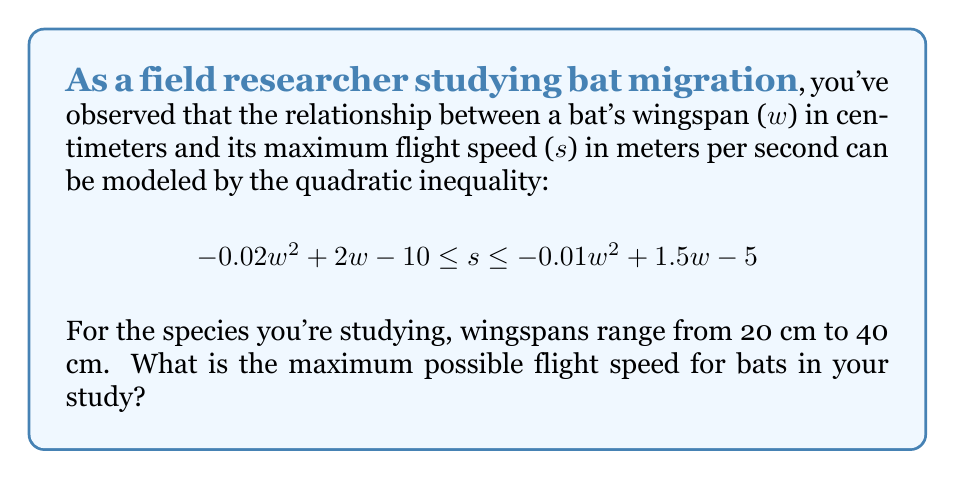Could you help me with this problem? 1) We need to find the maximum value of s within the given range of w (20 ≤ w ≤ 40).

2) The upper bound of s is given by: $$s = -0.01w^2 + 1.5w - 5$$

3) To find the maximum value, we need to find the vertex of this parabola:
   $$w = \frac{-b}{2a} = \frac{-1.5}{2(-0.01)} = 75$$

4) However, this is outside our range of 20 ≤ w ≤ 40.

5) Therefore, the maximum will occur at one of the endpoints of our range.

6) Let's evaluate at w = 20 and w = 40:

   For w = 20: $$s = -0.01(20)^2 + 1.5(20) - 5 = 21$$
   
   For w = 40: $$s = -0.01(40)^2 + 1.5(40) - 5 = 31$$

7) The larger value is 31, occurring when w = 40.

Therefore, the maximum possible flight speed is 31 m/s.
Answer: 31 m/s 